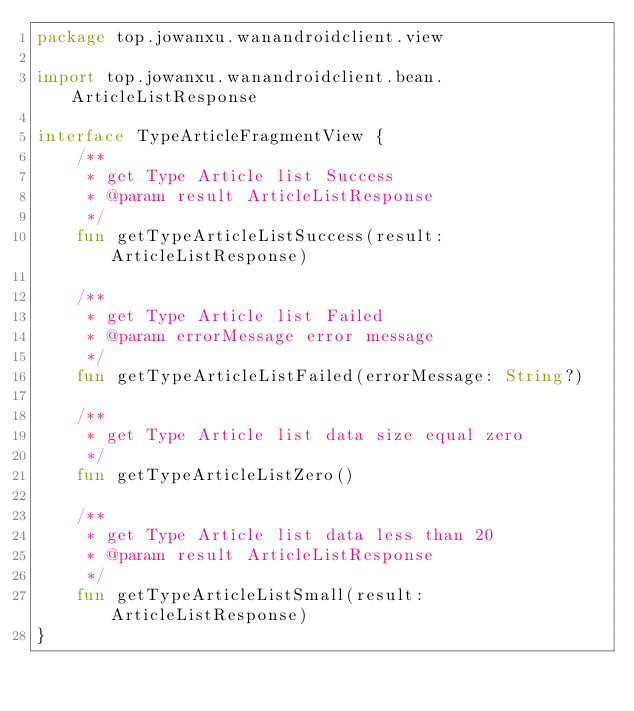<code> <loc_0><loc_0><loc_500><loc_500><_Kotlin_>package top.jowanxu.wanandroidclient.view

import top.jowanxu.wanandroidclient.bean.ArticleListResponse

interface TypeArticleFragmentView {
    /**
     * get Type Article list Success
     * @param result ArticleListResponse
     */
    fun getTypeArticleListSuccess(result: ArticleListResponse)

    /**
     * get Type Article list Failed
     * @param errorMessage error message
     */
    fun getTypeArticleListFailed(errorMessage: String?)

    /**
     * get Type Article list data size equal zero
     */
    fun getTypeArticleListZero()

    /**
     * get Type Article list data less than 20
     * @param result ArticleListResponse
     */
    fun getTypeArticleListSmall(result: ArticleListResponse)
}</code> 